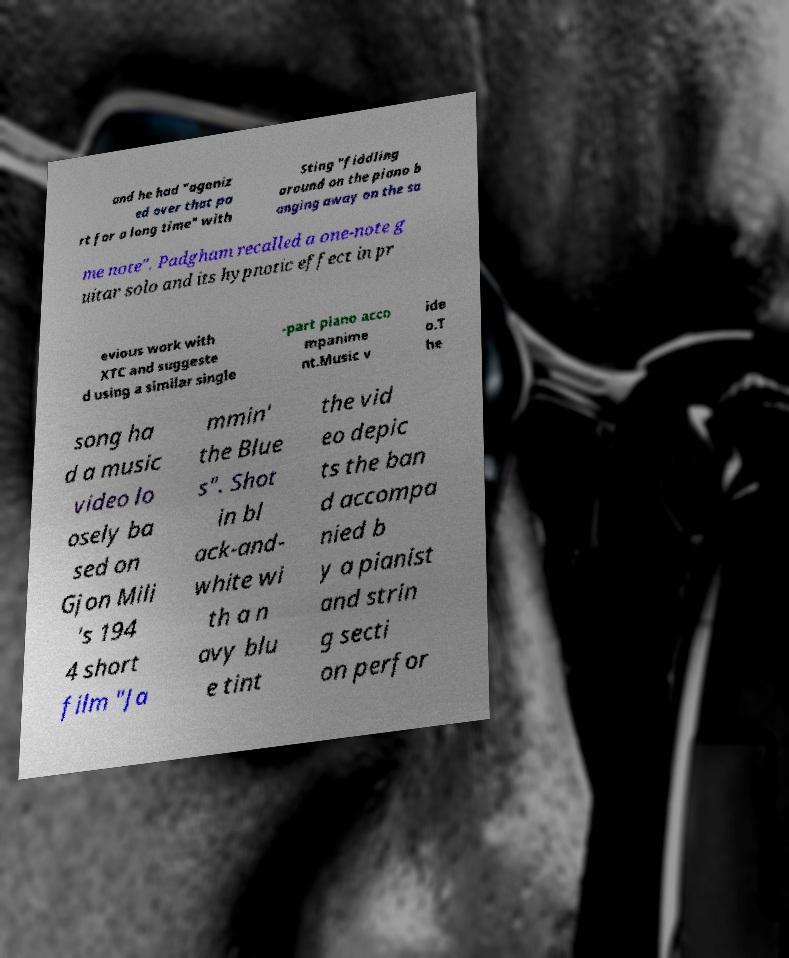Could you extract and type out the text from this image? and he had "agoniz ed over that pa rt for a long time" with Sting "fiddling around on the piano b anging away on the sa me note". Padgham recalled a one-note g uitar solo and its hypnotic effect in pr evious work with XTC and suggeste d using a similar single -part piano acco mpanime nt.Music v ide o.T he song ha d a music video lo osely ba sed on Gjon Mili 's 194 4 short film "Ja mmin' the Blue s". Shot in bl ack-and- white wi th a n avy blu e tint the vid eo depic ts the ban d accompa nied b y a pianist and strin g secti on perfor 